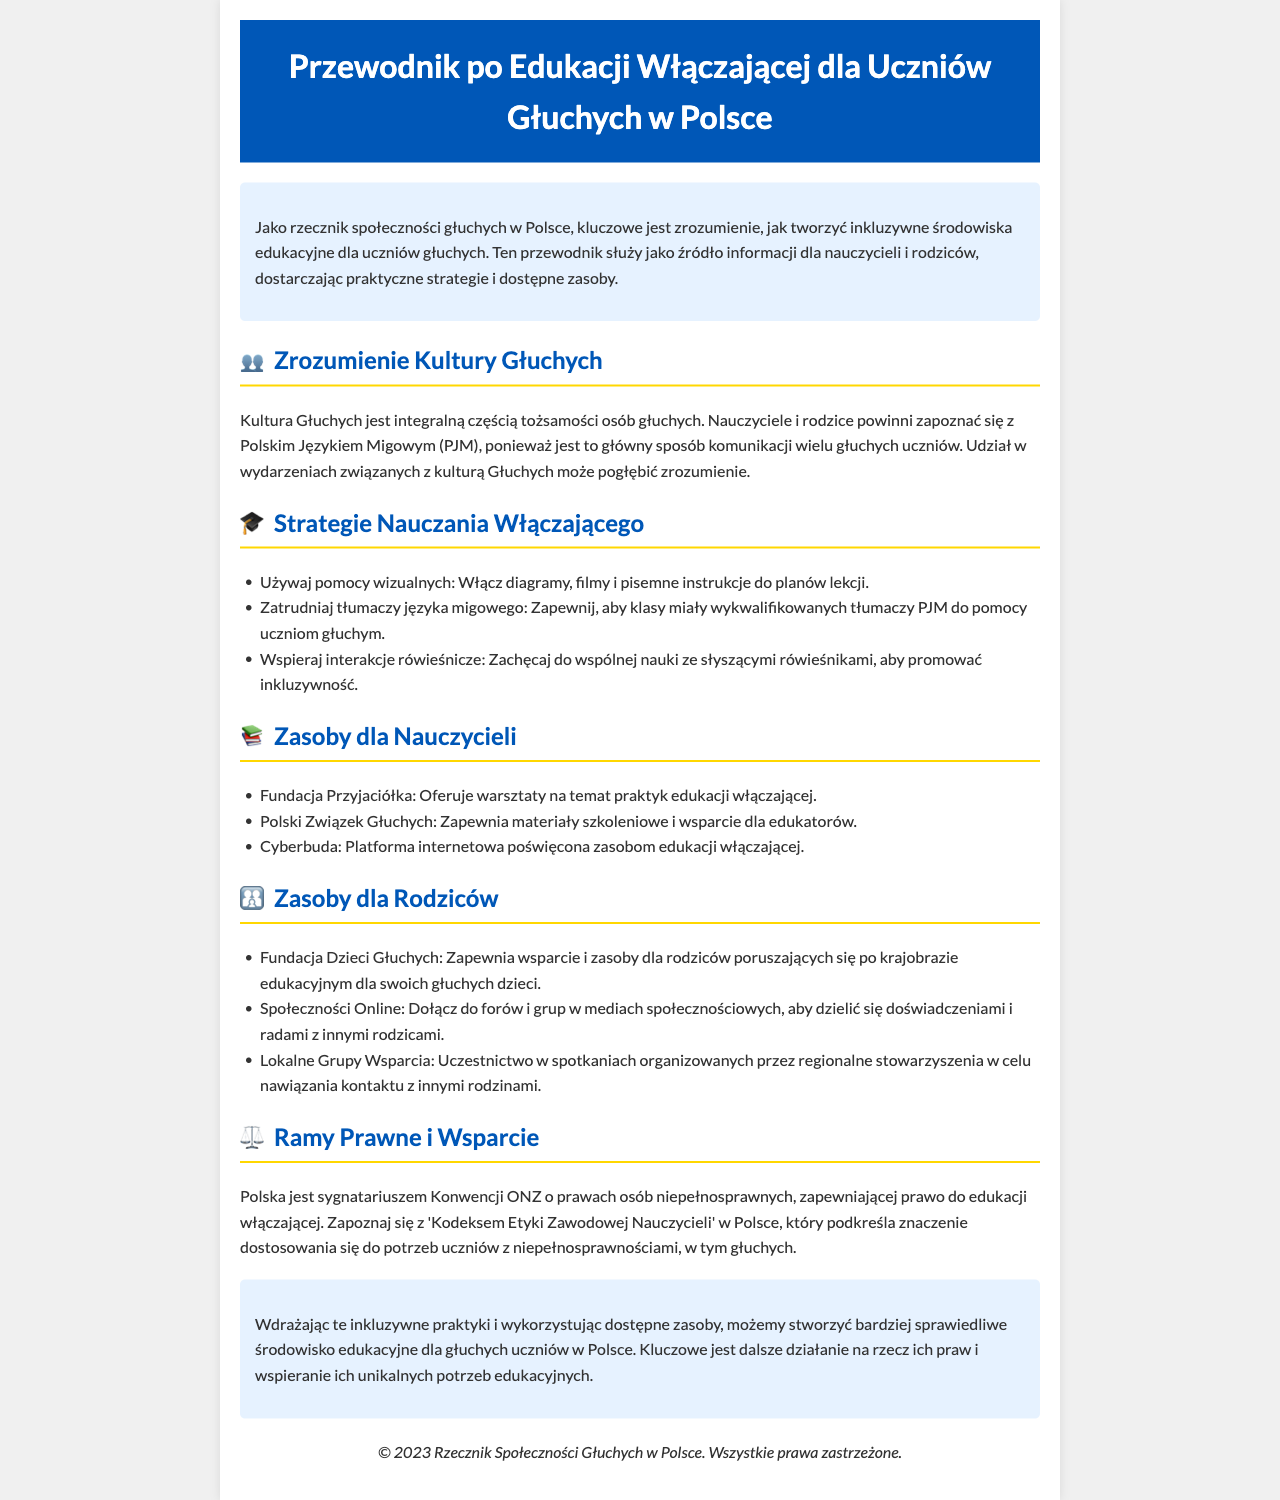Jakie są kluczowe kulturze Głuchych? Kultura Głuchych jest integralną częścią tożsamości osób głuchych i wymaga zrozumienia zarówno przez nauczycieli, jak i rodziców.
Answer: kultura Głuchych Jakie pomoce wizualne można używać w nauczaniu? W dokumentcie wymienione są pomoce wizualne jako jedna z praktyk w nauczaniu włączającym, takie jak diagramy, filmy i pisemne instrukcje.
Answer: diagramy, filmy, pisemne instrukcje Która fundacja oferuje warsztaty na temat edukacji włączającej? Dokument wskazuje Fundację Przyjaciółka jako organizację oferującą takie warsztaty.
Answer: Fundacja Przyjaciółka Jakie wsparcie oferuje Fundacja Dzieci Głuchych? Fundacja Dzieci Głuchych zapewnia rodzicom wsparcie oraz zasoby w obszarze edukacji ich dzieci.
Answer: wsparcie i zasoby Jaka konwencja chroni prawo do edukacji włączającej w Polsce? W dokumencie wskazano, że Polska jest sygnatariuszem Konwencji ONZ o prawach osób niepełnosprawnych, która zapewnia to prawo.
Answer: Konwencja ONZ o prawach osób niepełnosprawnych 